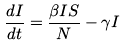Convert formula to latex. <formula><loc_0><loc_0><loc_500><loc_500>\frac { d I } { d t } = \frac { \beta I S } { N } - \gamma I</formula> 